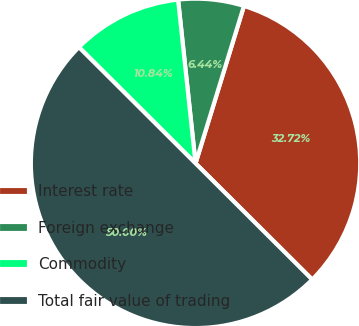Convert chart. <chart><loc_0><loc_0><loc_500><loc_500><pie_chart><fcel>Interest rate<fcel>Foreign exchange<fcel>Commodity<fcel>Total fair value of trading<nl><fcel>32.72%<fcel>6.44%<fcel>10.84%<fcel>50.0%<nl></chart> 